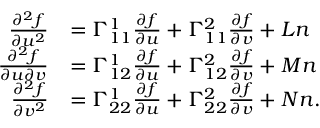Convert formula to latex. <formula><loc_0><loc_0><loc_500><loc_500>{ \begin{array} { r l } { { \frac { \partial ^ { 2 } f } { \partial u ^ { 2 } } } } & { = \Gamma _ { 1 1 } ^ { 1 } { \frac { \partial f } { \partial u } } + \Gamma _ { 1 1 } ^ { 2 } { \frac { \partial f } { \partial v } } + L n } \\ { { \frac { \partial ^ { 2 } f } { \partial u \partial v } } } & { = \Gamma _ { 1 2 } ^ { 1 } { \frac { \partial f } { \partial u } } + \Gamma _ { 1 2 } ^ { 2 } { \frac { \partial f } { \partial v } } + M n } \\ { { \frac { \partial ^ { 2 } f } { \partial v ^ { 2 } } } } & { = \Gamma _ { 2 2 } ^ { 1 } { \frac { \partial f } { \partial u } } + \Gamma _ { 2 2 } ^ { 2 } { \frac { \partial f } { \partial v } } + N n . } \end{array} }</formula> 